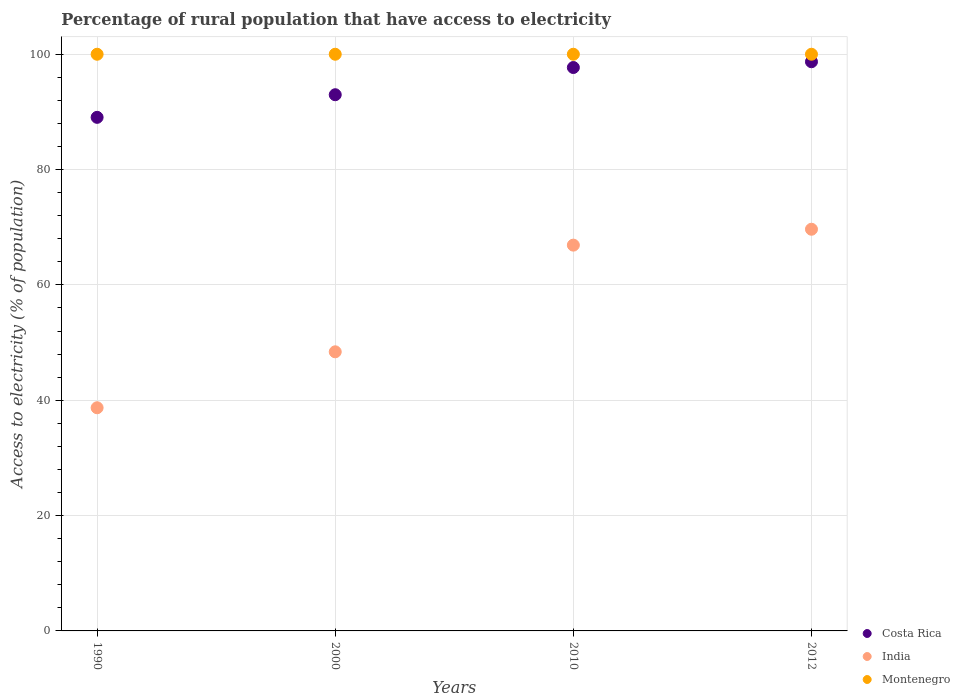What is the percentage of rural population that have access to electricity in Costa Rica in 2012?
Make the answer very short. 98.7. Across all years, what is the maximum percentage of rural population that have access to electricity in India?
Provide a short and direct response. 69.65. Across all years, what is the minimum percentage of rural population that have access to electricity in India?
Provide a short and direct response. 38.7. In which year was the percentage of rural population that have access to electricity in Montenegro maximum?
Ensure brevity in your answer.  1990. What is the total percentage of rural population that have access to electricity in India in the graph?
Keep it short and to the point. 223.65. What is the difference between the percentage of rural population that have access to electricity in Montenegro in 1990 and that in 2012?
Ensure brevity in your answer.  0. What is the difference between the percentage of rural population that have access to electricity in Montenegro in 2000 and the percentage of rural population that have access to electricity in India in 2012?
Keep it short and to the point. 30.35. What is the average percentage of rural population that have access to electricity in Montenegro per year?
Keep it short and to the point. 100. In the year 2010, what is the difference between the percentage of rural population that have access to electricity in Costa Rica and percentage of rural population that have access to electricity in India?
Your response must be concise. 30.8. In how many years, is the percentage of rural population that have access to electricity in Costa Rica greater than 80 %?
Keep it short and to the point. 4. What is the ratio of the percentage of rural population that have access to electricity in India in 1990 to that in 2000?
Keep it short and to the point. 0.8. What is the difference between the highest and the second highest percentage of rural population that have access to electricity in India?
Make the answer very short. 2.75. What is the difference between the highest and the lowest percentage of rural population that have access to electricity in India?
Your answer should be very brief. 30.95. Does the percentage of rural population that have access to electricity in Montenegro monotonically increase over the years?
Give a very brief answer. No. How many dotlines are there?
Provide a succinct answer. 3. What is the difference between two consecutive major ticks on the Y-axis?
Your answer should be compact. 20. Are the values on the major ticks of Y-axis written in scientific E-notation?
Offer a very short reply. No. Does the graph contain grids?
Offer a very short reply. Yes. Where does the legend appear in the graph?
Ensure brevity in your answer.  Bottom right. What is the title of the graph?
Offer a very short reply. Percentage of rural population that have access to electricity. What is the label or title of the X-axis?
Make the answer very short. Years. What is the label or title of the Y-axis?
Keep it short and to the point. Access to electricity (% of population). What is the Access to electricity (% of population) in Costa Rica in 1990?
Your answer should be very brief. 89.06. What is the Access to electricity (% of population) of India in 1990?
Offer a terse response. 38.7. What is the Access to electricity (% of population) in Costa Rica in 2000?
Give a very brief answer. 92.98. What is the Access to electricity (% of population) of India in 2000?
Offer a very short reply. 48.4. What is the Access to electricity (% of population) of Costa Rica in 2010?
Provide a succinct answer. 97.7. What is the Access to electricity (% of population) in India in 2010?
Your answer should be very brief. 66.9. What is the Access to electricity (% of population) of Montenegro in 2010?
Make the answer very short. 100. What is the Access to electricity (% of population) in Costa Rica in 2012?
Make the answer very short. 98.7. What is the Access to electricity (% of population) in India in 2012?
Your answer should be very brief. 69.65. Across all years, what is the maximum Access to electricity (% of population) in Costa Rica?
Provide a succinct answer. 98.7. Across all years, what is the maximum Access to electricity (% of population) in India?
Give a very brief answer. 69.65. Across all years, what is the minimum Access to electricity (% of population) in Costa Rica?
Your answer should be compact. 89.06. Across all years, what is the minimum Access to electricity (% of population) of India?
Provide a short and direct response. 38.7. What is the total Access to electricity (% of population) in Costa Rica in the graph?
Keep it short and to the point. 378.44. What is the total Access to electricity (% of population) of India in the graph?
Your answer should be compact. 223.65. What is the difference between the Access to electricity (% of population) in Costa Rica in 1990 and that in 2000?
Provide a short and direct response. -3.92. What is the difference between the Access to electricity (% of population) of India in 1990 and that in 2000?
Keep it short and to the point. -9.7. What is the difference between the Access to electricity (% of population) in Montenegro in 1990 and that in 2000?
Provide a short and direct response. 0. What is the difference between the Access to electricity (% of population) of Costa Rica in 1990 and that in 2010?
Provide a short and direct response. -8.64. What is the difference between the Access to electricity (% of population) in India in 1990 and that in 2010?
Give a very brief answer. -28.2. What is the difference between the Access to electricity (% of population) of Costa Rica in 1990 and that in 2012?
Provide a succinct answer. -9.64. What is the difference between the Access to electricity (% of population) of India in 1990 and that in 2012?
Offer a terse response. -30.95. What is the difference between the Access to electricity (% of population) of Montenegro in 1990 and that in 2012?
Provide a succinct answer. 0. What is the difference between the Access to electricity (% of population) in Costa Rica in 2000 and that in 2010?
Keep it short and to the point. -4.72. What is the difference between the Access to electricity (% of population) of India in 2000 and that in 2010?
Your answer should be compact. -18.5. What is the difference between the Access to electricity (% of population) of Costa Rica in 2000 and that in 2012?
Ensure brevity in your answer.  -5.72. What is the difference between the Access to electricity (% of population) of India in 2000 and that in 2012?
Your answer should be compact. -21.25. What is the difference between the Access to electricity (% of population) of Costa Rica in 2010 and that in 2012?
Give a very brief answer. -1. What is the difference between the Access to electricity (% of population) of India in 2010 and that in 2012?
Provide a succinct answer. -2.75. What is the difference between the Access to electricity (% of population) of Montenegro in 2010 and that in 2012?
Your answer should be compact. 0. What is the difference between the Access to electricity (% of population) of Costa Rica in 1990 and the Access to electricity (% of population) of India in 2000?
Ensure brevity in your answer.  40.66. What is the difference between the Access to electricity (% of population) in Costa Rica in 1990 and the Access to electricity (% of population) in Montenegro in 2000?
Your response must be concise. -10.94. What is the difference between the Access to electricity (% of population) in India in 1990 and the Access to electricity (% of population) in Montenegro in 2000?
Provide a succinct answer. -61.3. What is the difference between the Access to electricity (% of population) in Costa Rica in 1990 and the Access to electricity (% of population) in India in 2010?
Offer a terse response. 22.16. What is the difference between the Access to electricity (% of population) in Costa Rica in 1990 and the Access to electricity (% of population) in Montenegro in 2010?
Offer a very short reply. -10.94. What is the difference between the Access to electricity (% of population) in India in 1990 and the Access to electricity (% of population) in Montenegro in 2010?
Keep it short and to the point. -61.3. What is the difference between the Access to electricity (% of population) of Costa Rica in 1990 and the Access to electricity (% of population) of India in 2012?
Your answer should be compact. 19.41. What is the difference between the Access to electricity (% of population) in Costa Rica in 1990 and the Access to electricity (% of population) in Montenegro in 2012?
Make the answer very short. -10.94. What is the difference between the Access to electricity (% of population) in India in 1990 and the Access to electricity (% of population) in Montenegro in 2012?
Your answer should be compact. -61.3. What is the difference between the Access to electricity (% of population) in Costa Rica in 2000 and the Access to electricity (% of population) in India in 2010?
Give a very brief answer. 26.08. What is the difference between the Access to electricity (% of population) of Costa Rica in 2000 and the Access to electricity (% of population) of Montenegro in 2010?
Your answer should be compact. -7.02. What is the difference between the Access to electricity (% of population) of India in 2000 and the Access to electricity (% of population) of Montenegro in 2010?
Your response must be concise. -51.6. What is the difference between the Access to electricity (% of population) in Costa Rica in 2000 and the Access to electricity (% of population) in India in 2012?
Keep it short and to the point. 23.33. What is the difference between the Access to electricity (% of population) of Costa Rica in 2000 and the Access to electricity (% of population) of Montenegro in 2012?
Keep it short and to the point. -7.02. What is the difference between the Access to electricity (% of population) in India in 2000 and the Access to electricity (% of population) in Montenegro in 2012?
Your answer should be compact. -51.6. What is the difference between the Access to electricity (% of population) in Costa Rica in 2010 and the Access to electricity (% of population) in India in 2012?
Offer a very short reply. 28.05. What is the difference between the Access to electricity (% of population) in Costa Rica in 2010 and the Access to electricity (% of population) in Montenegro in 2012?
Your response must be concise. -2.3. What is the difference between the Access to electricity (% of population) in India in 2010 and the Access to electricity (% of population) in Montenegro in 2012?
Your answer should be compact. -33.1. What is the average Access to electricity (% of population) of Costa Rica per year?
Provide a succinct answer. 94.61. What is the average Access to electricity (% of population) of India per year?
Offer a very short reply. 55.91. What is the average Access to electricity (% of population) in Montenegro per year?
Offer a terse response. 100. In the year 1990, what is the difference between the Access to electricity (% of population) in Costa Rica and Access to electricity (% of population) in India?
Your answer should be very brief. 50.36. In the year 1990, what is the difference between the Access to electricity (% of population) in Costa Rica and Access to electricity (% of population) in Montenegro?
Provide a succinct answer. -10.94. In the year 1990, what is the difference between the Access to electricity (% of population) in India and Access to electricity (% of population) in Montenegro?
Offer a terse response. -61.3. In the year 2000, what is the difference between the Access to electricity (% of population) of Costa Rica and Access to electricity (% of population) of India?
Your answer should be compact. 44.58. In the year 2000, what is the difference between the Access to electricity (% of population) of Costa Rica and Access to electricity (% of population) of Montenegro?
Make the answer very short. -7.02. In the year 2000, what is the difference between the Access to electricity (% of population) in India and Access to electricity (% of population) in Montenegro?
Keep it short and to the point. -51.6. In the year 2010, what is the difference between the Access to electricity (% of population) in Costa Rica and Access to electricity (% of population) in India?
Make the answer very short. 30.8. In the year 2010, what is the difference between the Access to electricity (% of population) of India and Access to electricity (% of population) of Montenegro?
Make the answer very short. -33.1. In the year 2012, what is the difference between the Access to electricity (% of population) of Costa Rica and Access to electricity (% of population) of India?
Your response must be concise. 29.05. In the year 2012, what is the difference between the Access to electricity (% of population) in Costa Rica and Access to electricity (% of population) in Montenegro?
Your answer should be compact. -1.3. In the year 2012, what is the difference between the Access to electricity (% of population) of India and Access to electricity (% of population) of Montenegro?
Your answer should be very brief. -30.35. What is the ratio of the Access to electricity (% of population) in Costa Rica in 1990 to that in 2000?
Give a very brief answer. 0.96. What is the ratio of the Access to electricity (% of population) in India in 1990 to that in 2000?
Your response must be concise. 0.8. What is the ratio of the Access to electricity (% of population) in Costa Rica in 1990 to that in 2010?
Make the answer very short. 0.91. What is the ratio of the Access to electricity (% of population) of India in 1990 to that in 2010?
Provide a short and direct response. 0.58. What is the ratio of the Access to electricity (% of population) of Montenegro in 1990 to that in 2010?
Provide a short and direct response. 1. What is the ratio of the Access to electricity (% of population) of Costa Rica in 1990 to that in 2012?
Provide a succinct answer. 0.9. What is the ratio of the Access to electricity (% of population) in India in 1990 to that in 2012?
Provide a succinct answer. 0.56. What is the ratio of the Access to electricity (% of population) of Montenegro in 1990 to that in 2012?
Your answer should be very brief. 1. What is the ratio of the Access to electricity (% of population) of Costa Rica in 2000 to that in 2010?
Offer a very short reply. 0.95. What is the ratio of the Access to electricity (% of population) of India in 2000 to that in 2010?
Make the answer very short. 0.72. What is the ratio of the Access to electricity (% of population) of Costa Rica in 2000 to that in 2012?
Ensure brevity in your answer.  0.94. What is the ratio of the Access to electricity (% of population) in India in 2000 to that in 2012?
Your answer should be compact. 0.69. What is the ratio of the Access to electricity (% of population) in Montenegro in 2000 to that in 2012?
Your answer should be compact. 1. What is the ratio of the Access to electricity (% of population) of Costa Rica in 2010 to that in 2012?
Your response must be concise. 0.99. What is the ratio of the Access to electricity (% of population) of India in 2010 to that in 2012?
Give a very brief answer. 0.96. What is the ratio of the Access to electricity (% of population) in Montenegro in 2010 to that in 2012?
Provide a short and direct response. 1. What is the difference between the highest and the second highest Access to electricity (% of population) in Costa Rica?
Offer a terse response. 1. What is the difference between the highest and the second highest Access to electricity (% of population) of India?
Your response must be concise. 2.75. What is the difference between the highest and the second highest Access to electricity (% of population) of Montenegro?
Give a very brief answer. 0. What is the difference between the highest and the lowest Access to electricity (% of population) of Costa Rica?
Make the answer very short. 9.64. What is the difference between the highest and the lowest Access to electricity (% of population) in India?
Provide a succinct answer. 30.95. 